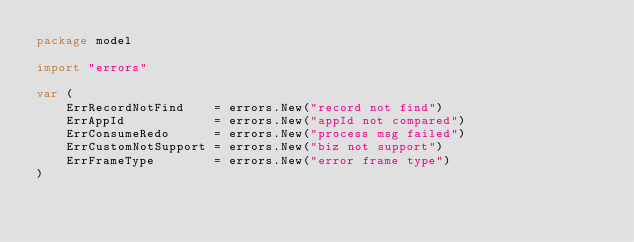<code> <loc_0><loc_0><loc_500><loc_500><_Go_>package model

import "errors"

var (
	ErrRecordNotFind    = errors.New("record not find")
	ErrAppId            = errors.New("appId not compared")
	ErrConsumeRedo      = errors.New("process msg failed")
	ErrCustomNotSupport = errors.New("biz not support")
	ErrFrameType        = errors.New("error frame type")
)
</code> 